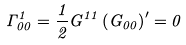<formula> <loc_0><loc_0><loc_500><loc_500>\Gamma _ { 0 0 } ^ { 1 } = \frac { 1 } { 2 } G ^ { 1 1 } \left ( G _ { 0 0 } \right ) ^ { \prime } = 0</formula> 